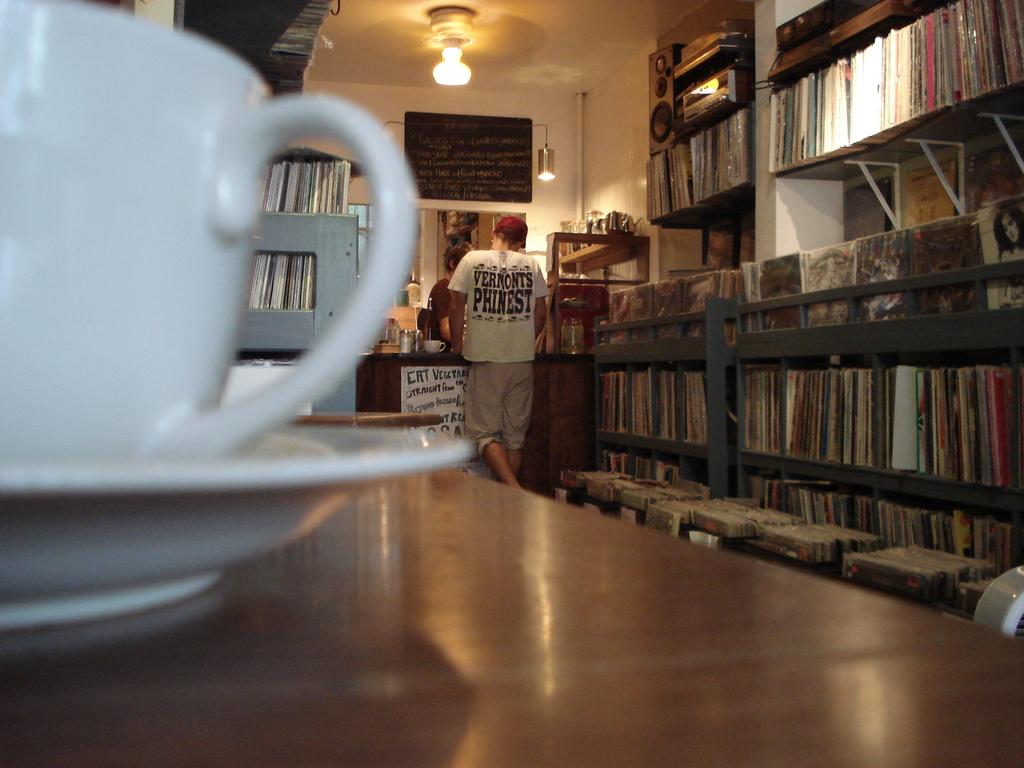What could be inside the cup?
Offer a very short reply. Answering does not require reading text in the image. 